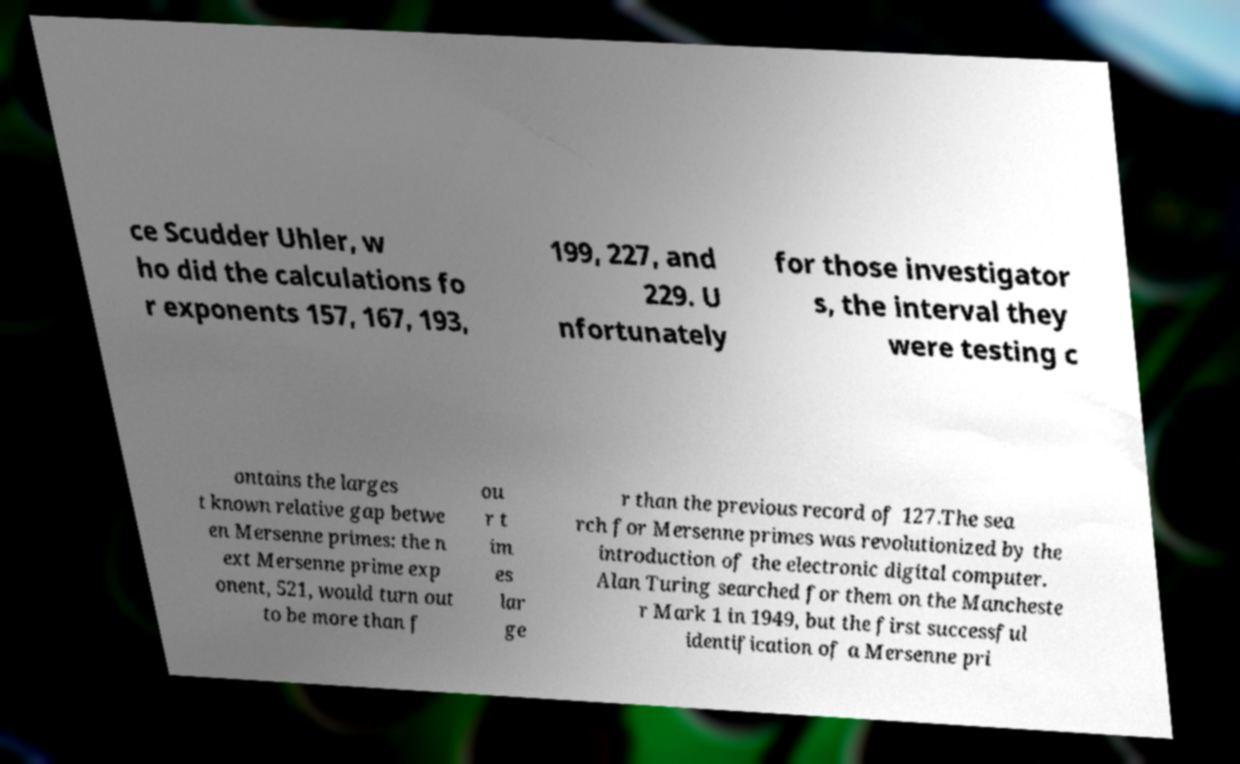Could you extract and type out the text from this image? ce Scudder Uhler, w ho did the calculations fo r exponents 157, 167, 193, 199, 227, and 229. U nfortunately for those investigator s, the interval they were testing c ontains the larges t known relative gap betwe en Mersenne primes: the n ext Mersenne prime exp onent, 521, would turn out to be more than f ou r t im es lar ge r than the previous record of 127.The sea rch for Mersenne primes was revolutionized by the introduction of the electronic digital computer. Alan Turing searched for them on the Mancheste r Mark 1 in 1949, but the first successful identification of a Mersenne pri 